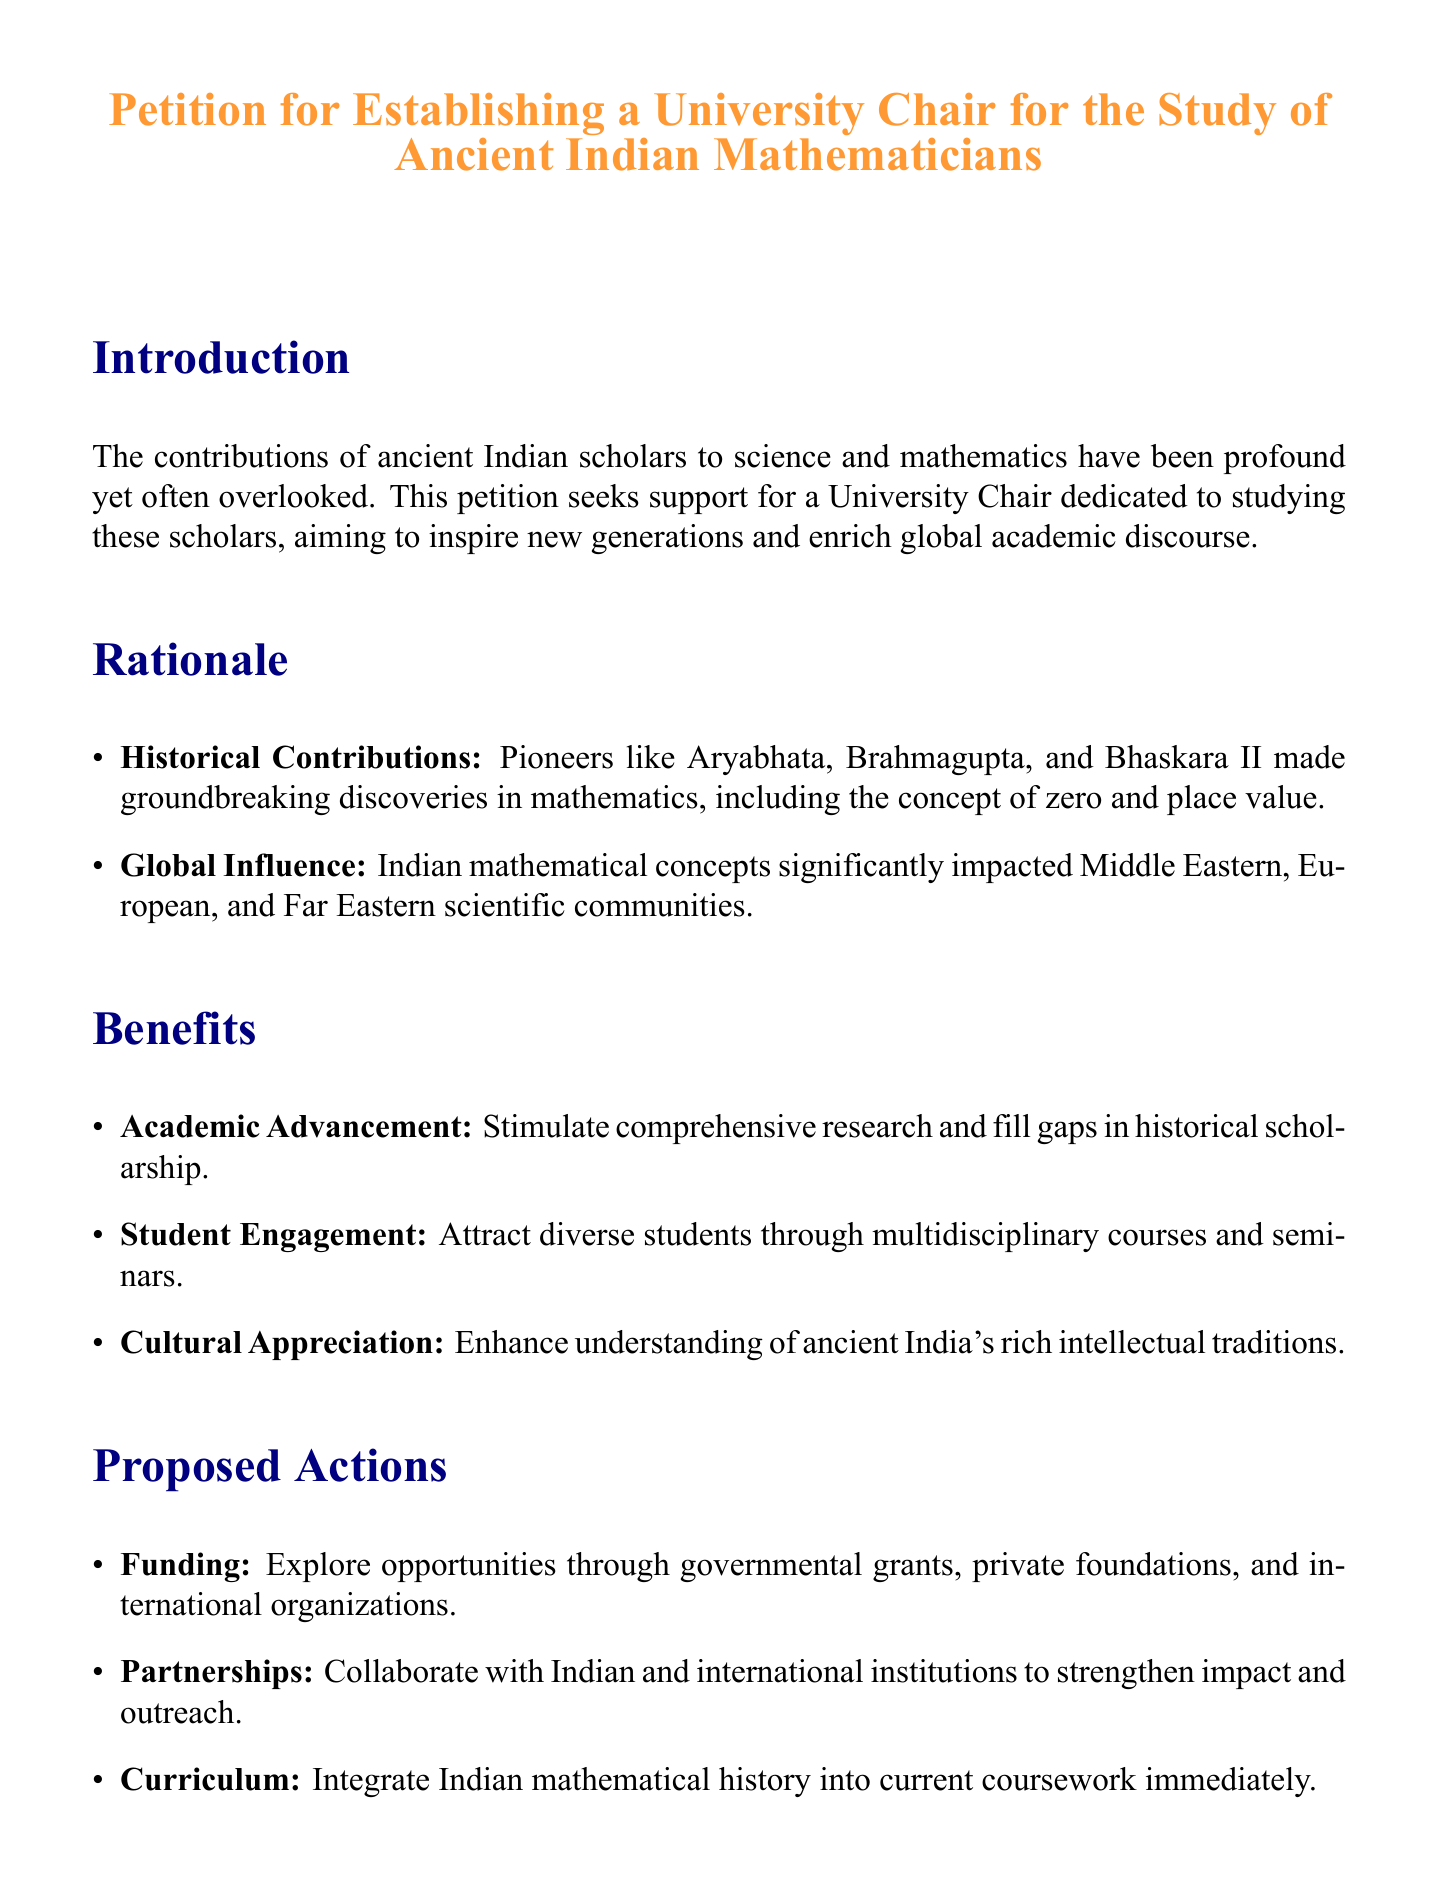What is the title of the petition? The title of the petition is explicitly stated at the beginning of the document.
Answer: Petition for Establishing a University Chair for the Study of Ancient Indian Mathematicians Who are some of the ancient Indian mathematicians mentioned? The document lists specific mathematicians who made notable contributions to the field.
Answer: Aryabhata, Brahmagupta, Bhaskara II What does the petition aim to inspire? The purpose of the petition is highlighted in the introduction regarding its impact on future generations.
Answer: New generations What are two proposed actions mentioned in the document? The document outlines specific actions that will be taken to support the establishment of the Chair.
Answer: Funding, Partnerships What is one benefit of establishing the Chair? The document states several benefits that would arise from the establishment of the Chair.
Answer: Academic Advancement How many signatures are there for the petition? The document includes a section for signatures, indicating the participation level in the petition.
Answer: Four 